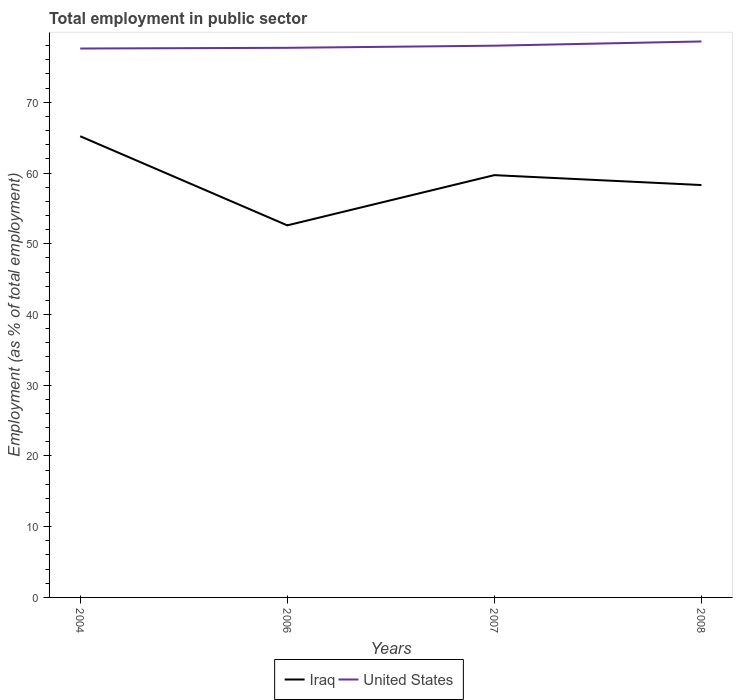How many different coloured lines are there?
Your answer should be compact. 2. Does the line corresponding to United States intersect with the line corresponding to Iraq?
Offer a terse response. No. Is the number of lines equal to the number of legend labels?
Your response must be concise. Yes. Across all years, what is the maximum employment in public sector in United States?
Ensure brevity in your answer.  77.6. What is the total employment in public sector in Iraq in the graph?
Provide a succinct answer. 12.6. What is the difference between the highest and the second highest employment in public sector in Iraq?
Make the answer very short. 12.6. What is the difference between the highest and the lowest employment in public sector in Iraq?
Offer a very short reply. 2. How many years are there in the graph?
Ensure brevity in your answer.  4. What is the difference between two consecutive major ticks on the Y-axis?
Ensure brevity in your answer.  10. Are the values on the major ticks of Y-axis written in scientific E-notation?
Offer a very short reply. No. Does the graph contain any zero values?
Offer a very short reply. No. How many legend labels are there?
Offer a very short reply. 2. How are the legend labels stacked?
Make the answer very short. Horizontal. What is the title of the graph?
Offer a terse response. Total employment in public sector. Does "Botswana" appear as one of the legend labels in the graph?
Your answer should be very brief. No. What is the label or title of the X-axis?
Your response must be concise. Years. What is the label or title of the Y-axis?
Your answer should be very brief. Employment (as % of total employment). What is the Employment (as % of total employment) in Iraq in 2004?
Keep it short and to the point. 65.2. What is the Employment (as % of total employment) in United States in 2004?
Offer a terse response. 77.6. What is the Employment (as % of total employment) of Iraq in 2006?
Make the answer very short. 52.6. What is the Employment (as % of total employment) in United States in 2006?
Keep it short and to the point. 77.7. What is the Employment (as % of total employment) in Iraq in 2007?
Offer a terse response. 59.7. What is the Employment (as % of total employment) of Iraq in 2008?
Provide a short and direct response. 58.3. What is the Employment (as % of total employment) in United States in 2008?
Offer a very short reply. 78.6. Across all years, what is the maximum Employment (as % of total employment) of Iraq?
Keep it short and to the point. 65.2. Across all years, what is the maximum Employment (as % of total employment) of United States?
Your answer should be compact. 78.6. Across all years, what is the minimum Employment (as % of total employment) of Iraq?
Your response must be concise. 52.6. Across all years, what is the minimum Employment (as % of total employment) of United States?
Offer a terse response. 77.6. What is the total Employment (as % of total employment) in Iraq in the graph?
Give a very brief answer. 235.8. What is the total Employment (as % of total employment) of United States in the graph?
Your response must be concise. 311.9. What is the difference between the Employment (as % of total employment) in Iraq in 2004 and that in 2006?
Keep it short and to the point. 12.6. What is the difference between the Employment (as % of total employment) of Iraq in 2004 and that in 2008?
Provide a succinct answer. 6.9. What is the difference between the Employment (as % of total employment) of United States in 2004 and that in 2008?
Your answer should be very brief. -1. What is the difference between the Employment (as % of total employment) in Iraq in 2006 and that in 2007?
Your response must be concise. -7.1. What is the difference between the Employment (as % of total employment) in United States in 2006 and that in 2007?
Your response must be concise. -0.3. What is the difference between the Employment (as % of total employment) of Iraq in 2006 and that in 2008?
Give a very brief answer. -5.7. What is the difference between the Employment (as % of total employment) of United States in 2006 and that in 2008?
Your answer should be very brief. -0.9. What is the difference between the Employment (as % of total employment) of Iraq in 2007 and that in 2008?
Make the answer very short. 1.4. What is the difference between the Employment (as % of total employment) of United States in 2007 and that in 2008?
Provide a succinct answer. -0.6. What is the difference between the Employment (as % of total employment) of Iraq in 2006 and the Employment (as % of total employment) of United States in 2007?
Your response must be concise. -25.4. What is the difference between the Employment (as % of total employment) in Iraq in 2006 and the Employment (as % of total employment) in United States in 2008?
Offer a very short reply. -26. What is the difference between the Employment (as % of total employment) of Iraq in 2007 and the Employment (as % of total employment) of United States in 2008?
Your response must be concise. -18.9. What is the average Employment (as % of total employment) of Iraq per year?
Provide a succinct answer. 58.95. What is the average Employment (as % of total employment) of United States per year?
Give a very brief answer. 77.97. In the year 2006, what is the difference between the Employment (as % of total employment) of Iraq and Employment (as % of total employment) of United States?
Give a very brief answer. -25.1. In the year 2007, what is the difference between the Employment (as % of total employment) of Iraq and Employment (as % of total employment) of United States?
Make the answer very short. -18.3. In the year 2008, what is the difference between the Employment (as % of total employment) of Iraq and Employment (as % of total employment) of United States?
Your response must be concise. -20.3. What is the ratio of the Employment (as % of total employment) in Iraq in 2004 to that in 2006?
Provide a short and direct response. 1.24. What is the ratio of the Employment (as % of total employment) of Iraq in 2004 to that in 2007?
Your answer should be very brief. 1.09. What is the ratio of the Employment (as % of total employment) of Iraq in 2004 to that in 2008?
Offer a terse response. 1.12. What is the ratio of the Employment (as % of total employment) in United States in 2004 to that in 2008?
Provide a short and direct response. 0.99. What is the ratio of the Employment (as % of total employment) in Iraq in 2006 to that in 2007?
Give a very brief answer. 0.88. What is the ratio of the Employment (as % of total employment) of Iraq in 2006 to that in 2008?
Offer a terse response. 0.9. What is the ratio of the Employment (as % of total employment) of United States in 2007 to that in 2008?
Make the answer very short. 0.99. What is the difference between the highest and the second highest Employment (as % of total employment) of United States?
Provide a short and direct response. 0.6. What is the difference between the highest and the lowest Employment (as % of total employment) of Iraq?
Your answer should be compact. 12.6. What is the difference between the highest and the lowest Employment (as % of total employment) in United States?
Make the answer very short. 1. 